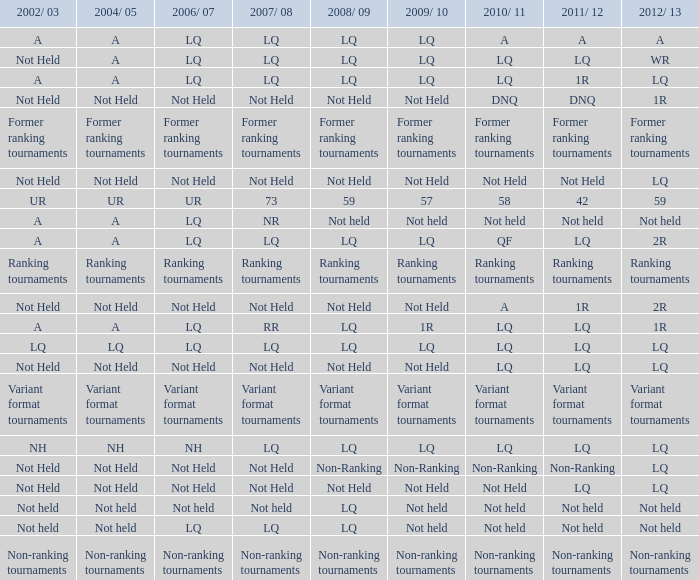Name the 2010/11 with 2004/05 of not held and 2011/12 of non-ranking Non-Ranking. 